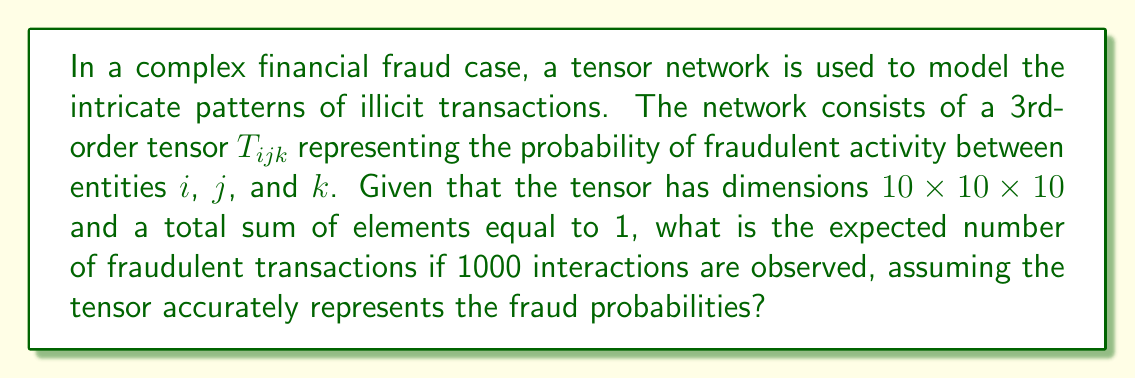Show me your answer to this math problem. To solve this problem, we'll follow these steps:

1) First, we need to understand what the tensor $T_{ijk}$ represents. Each element of this tensor gives the probability of a fraudulent transaction involving entities $i$, $j$, and $k$.

2) The tensor has dimensions $10 \times 10 \times 10$, meaning there are 1000 possible combinations of entities.

3) We're told that the sum of all elements in the tensor equals 1. This can be expressed mathematically as:

   $$\sum_{i=1}^{10} \sum_{j=1}^{10} \sum_{k=1}^{10} T_{ijk} = 1$$

4) This sum represents the total probability of fraud across all possible entity combinations.

5) Now, we need to calculate the expected number of fraudulent transactions in 1000 interactions. In probability theory, the expected value is calculated by multiplying the probability of an event by the number of trials.

6) In this case, the probability of fraud for any given transaction is the sum of all elements in the tensor, which is 1.

7) Therefore, the expected number of fraudulent transactions is:

   $$E(\text{fraudulent transactions}) = 1000 \times 1 = 1000$$

This means that if the tensor accurately represents the fraud probabilities and 1000 interactions are observed, we would expect all 1000 interactions to be fraudulent.
Answer: 1000 fraudulent transactions 